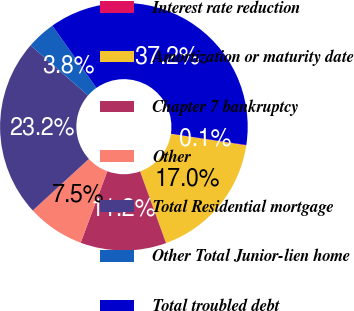<chart> <loc_0><loc_0><loc_500><loc_500><pie_chart><fcel>Interest rate reduction<fcel>Amortization or maturity date<fcel>Chapter 7 bankruptcy<fcel>Other<fcel>Total Residential mortgage<fcel>Other Total Junior-lien home<fcel>Total troubled debt<nl><fcel>0.08%<fcel>17.03%<fcel>11.2%<fcel>7.49%<fcel>23.24%<fcel>3.79%<fcel>37.16%<nl></chart> 